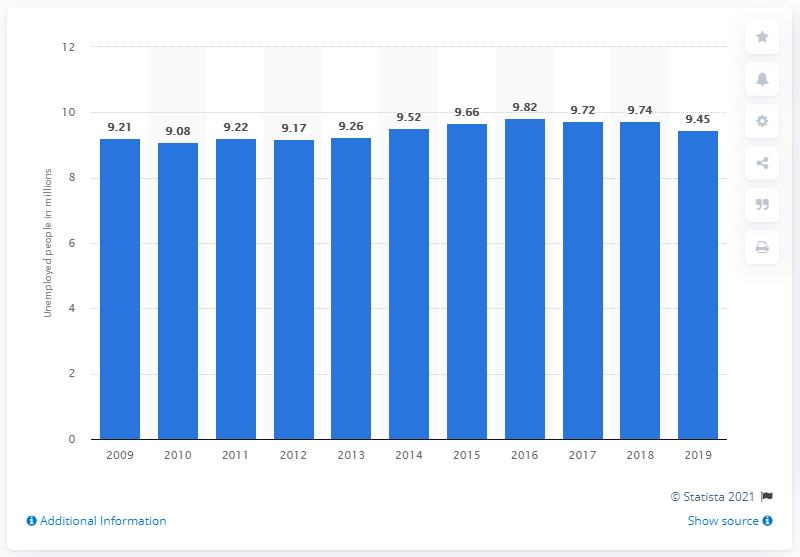Specify some key components in this picture. In 2019, approximately 9.45% of people living in urban areas of China were unemployed. There were 9.74 unemployed people in the previous year. 